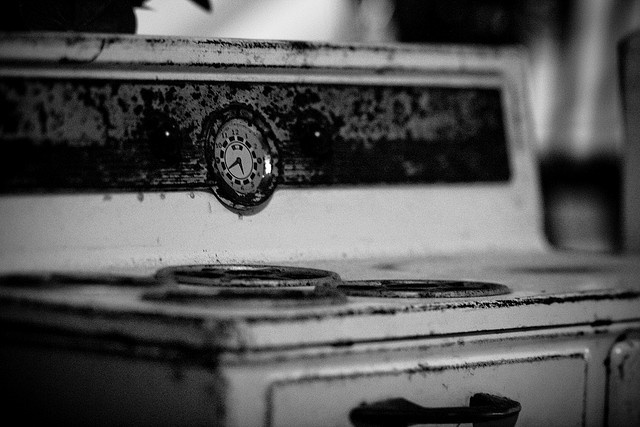Describe the objects in this image and their specific colors. I can see oven in black, darkgray, gray, and lightgray tones and clock in black, gray, and lightgray tones in this image. 